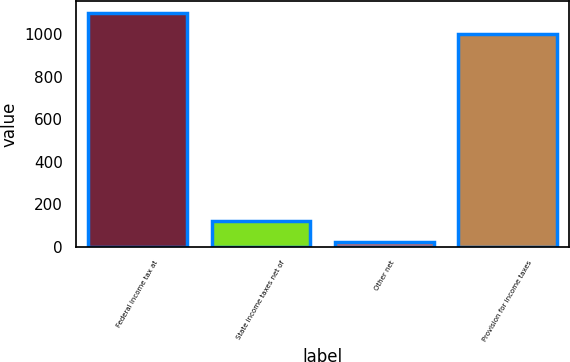Convert chart to OTSL. <chart><loc_0><loc_0><loc_500><loc_500><bar_chart><fcel>Federal income tax at<fcel>State income taxes net of<fcel>Other net<fcel>Provision for income taxes<nl><fcel>1102.1<fcel>120.1<fcel>20<fcel>1002<nl></chart> 